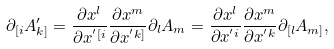Convert formula to latex. <formula><loc_0><loc_0><loc_500><loc_500>\partial _ { [ i } A ^ { \prime } _ { k ] } = \frac { \partial x ^ { l } } { \partial x ^ { ^ { \prime } [ i } } \frac { \partial x ^ { m } } { \partial x ^ { ^ { \prime } k ] } } \partial _ { l } A _ { m } = \frac { \partial x ^ { l } } { \partial x ^ { ^ { \prime } i } } \frac { \partial x ^ { m } } { \partial x ^ { ^ { \prime } k } } \partial _ { [ l } A _ { m ] } ,</formula> 